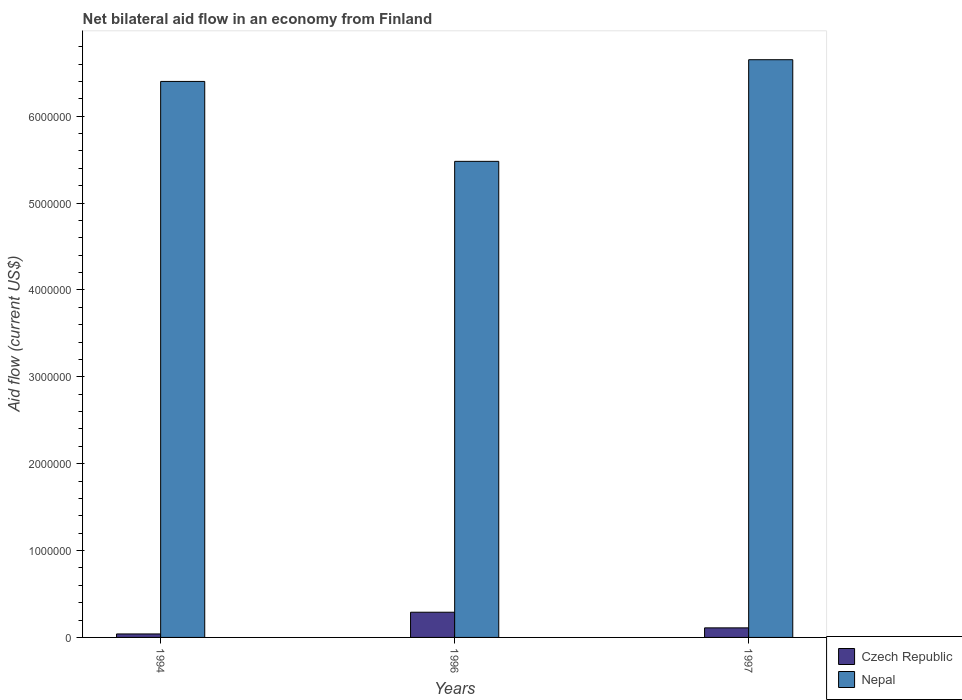Are the number of bars per tick equal to the number of legend labels?
Keep it short and to the point. Yes. Are the number of bars on each tick of the X-axis equal?
Provide a succinct answer. Yes. How many bars are there on the 2nd tick from the left?
Keep it short and to the point. 2. How many bars are there on the 1st tick from the right?
Keep it short and to the point. 2. What is the label of the 3rd group of bars from the left?
Offer a very short reply. 1997. Across all years, what is the maximum net bilateral aid flow in Nepal?
Provide a short and direct response. 6.65e+06. Across all years, what is the minimum net bilateral aid flow in Nepal?
Ensure brevity in your answer.  5.48e+06. What is the total net bilateral aid flow in Czech Republic in the graph?
Your answer should be compact. 4.40e+05. What is the difference between the net bilateral aid flow in Czech Republic in 1994 and that in 1996?
Ensure brevity in your answer.  -2.50e+05. What is the difference between the net bilateral aid flow in Nepal in 1996 and the net bilateral aid flow in Czech Republic in 1994?
Offer a terse response. 5.44e+06. What is the average net bilateral aid flow in Nepal per year?
Make the answer very short. 6.18e+06. In the year 1996, what is the difference between the net bilateral aid flow in Nepal and net bilateral aid flow in Czech Republic?
Your answer should be very brief. 5.19e+06. What is the ratio of the net bilateral aid flow in Czech Republic in 1994 to that in 1996?
Your answer should be very brief. 0.14. What is the difference between the highest and the second highest net bilateral aid flow in Nepal?
Offer a very short reply. 2.50e+05. What is the difference between the highest and the lowest net bilateral aid flow in Nepal?
Your response must be concise. 1.17e+06. What does the 1st bar from the left in 1997 represents?
Provide a succinct answer. Czech Republic. What does the 1st bar from the right in 1997 represents?
Keep it short and to the point. Nepal. What is the difference between two consecutive major ticks on the Y-axis?
Provide a short and direct response. 1.00e+06. Does the graph contain any zero values?
Your answer should be compact. No. Does the graph contain grids?
Keep it short and to the point. No. How many legend labels are there?
Your response must be concise. 2. How are the legend labels stacked?
Offer a terse response. Vertical. What is the title of the graph?
Offer a terse response. Net bilateral aid flow in an economy from Finland. What is the Aid flow (current US$) of Nepal in 1994?
Your response must be concise. 6.40e+06. What is the Aid flow (current US$) of Czech Republic in 1996?
Make the answer very short. 2.90e+05. What is the Aid flow (current US$) of Nepal in 1996?
Keep it short and to the point. 5.48e+06. What is the Aid flow (current US$) of Czech Republic in 1997?
Your answer should be very brief. 1.10e+05. What is the Aid flow (current US$) in Nepal in 1997?
Your answer should be very brief. 6.65e+06. Across all years, what is the maximum Aid flow (current US$) of Nepal?
Ensure brevity in your answer.  6.65e+06. Across all years, what is the minimum Aid flow (current US$) in Czech Republic?
Ensure brevity in your answer.  4.00e+04. Across all years, what is the minimum Aid flow (current US$) in Nepal?
Keep it short and to the point. 5.48e+06. What is the total Aid flow (current US$) in Czech Republic in the graph?
Offer a terse response. 4.40e+05. What is the total Aid flow (current US$) of Nepal in the graph?
Make the answer very short. 1.85e+07. What is the difference between the Aid flow (current US$) of Nepal in 1994 and that in 1996?
Your answer should be compact. 9.20e+05. What is the difference between the Aid flow (current US$) of Nepal in 1994 and that in 1997?
Provide a succinct answer. -2.50e+05. What is the difference between the Aid flow (current US$) in Nepal in 1996 and that in 1997?
Ensure brevity in your answer.  -1.17e+06. What is the difference between the Aid flow (current US$) of Czech Republic in 1994 and the Aid flow (current US$) of Nepal in 1996?
Your answer should be compact. -5.44e+06. What is the difference between the Aid flow (current US$) of Czech Republic in 1994 and the Aid flow (current US$) of Nepal in 1997?
Give a very brief answer. -6.61e+06. What is the difference between the Aid flow (current US$) of Czech Republic in 1996 and the Aid flow (current US$) of Nepal in 1997?
Provide a succinct answer. -6.36e+06. What is the average Aid flow (current US$) of Czech Republic per year?
Offer a very short reply. 1.47e+05. What is the average Aid flow (current US$) in Nepal per year?
Your answer should be compact. 6.18e+06. In the year 1994, what is the difference between the Aid flow (current US$) in Czech Republic and Aid flow (current US$) in Nepal?
Keep it short and to the point. -6.36e+06. In the year 1996, what is the difference between the Aid flow (current US$) of Czech Republic and Aid flow (current US$) of Nepal?
Your response must be concise. -5.19e+06. In the year 1997, what is the difference between the Aid flow (current US$) of Czech Republic and Aid flow (current US$) of Nepal?
Give a very brief answer. -6.54e+06. What is the ratio of the Aid flow (current US$) of Czech Republic in 1994 to that in 1996?
Make the answer very short. 0.14. What is the ratio of the Aid flow (current US$) in Nepal in 1994 to that in 1996?
Your answer should be very brief. 1.17. What is the ratio of the Aid flow (current US$) in Czech Republic in 1994 to that in 1997?
Provide a short and direct response. 0.36. What is the ratio of the Aid flow (current US$) in Nepal in 1994 to that in 1997?
Your answer should be very brief. 0.96. What is the ratio of the Aid flow (current US$) in Czech Republic in 1996 to that in 1997?
Offer a terse response. 2.64. What is the ratio of the Aid flow (current US$) of Nepal in 1996 to that in 1997?
Your answer should be very brief. 0.82. What is the difference between the highest and the second highest Aid flow (current US$) in Czech Republic?
Your answer should be very brief. 1.80e+05. What is the difference between the highest and the lowest Aid flow (current US$) of Czech Republic?
Your response must be concise. 2.50e+05. What is the difference between the highest and the lowest Aid flow (current US$) of Nepal?
Your answer should be compact. 1.17e+06. 